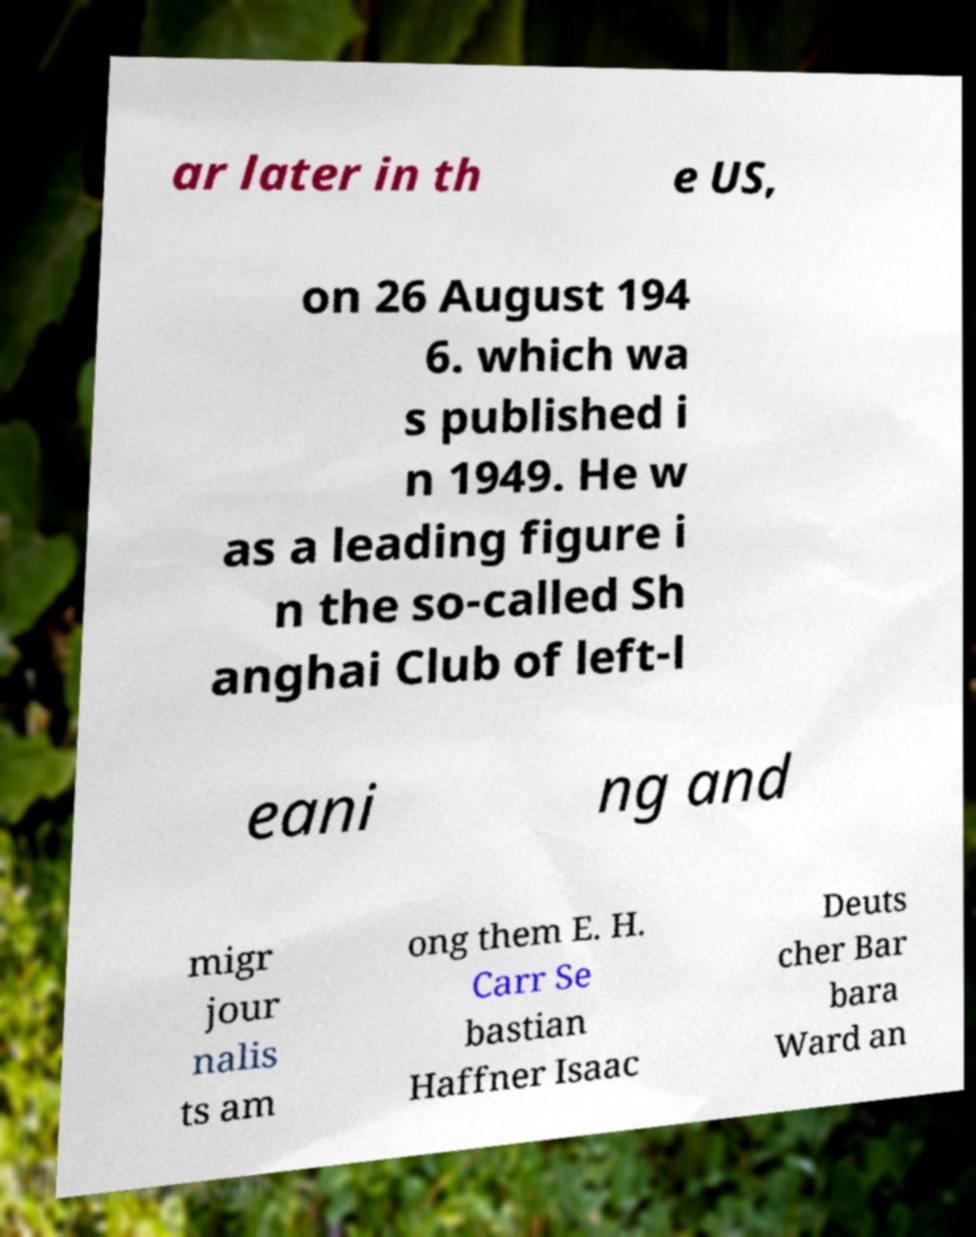I need the written content from this picture converted into text. Can you do that? ar later in th e US, on 26 August 194 6. which wa s published i n 1949. He w as a leading figure i n the so-called Sh anghai Club of left-l eani ng and migr jour nalis ts am ong them E. H. Carr Se bastian Haffner Isaac Deuts cher Bar bara Ward an 